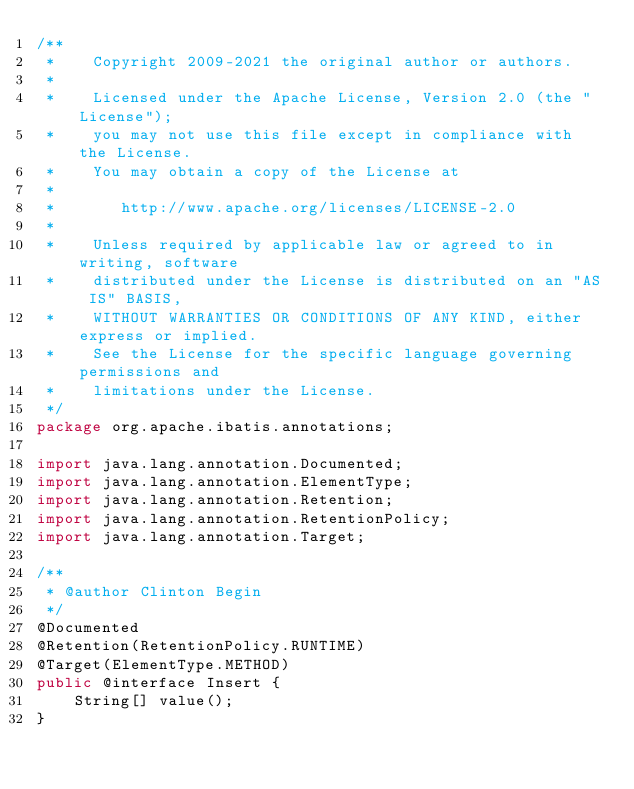<code> <loc_0><loc_0><loc_500><loc_500><_Java_>/**
 *    Copyright 2009-2021 the original author or authors.
 *
 *    Licensed under the Apache License, Version 2.0 (the "License");
 *    you may not use this file except in compliance with the License.
 *    You may obtain a copy of the License at
 *
 *       http://www.apache.org/licenses/LICENSE-2.0
 *
 *    Unless required by applicable law or agreed to in writing, software
 *    distributed under the License is distributed on an "AS IS" BASIS,
 *    WITHOUT WARRANTIES OR CONDITIONS OF ANY KIND, either express or implied.
 *    See the License for the specific language governing permissions and
 *    limitations under the License.
 */
package org.apache.ibatis.annotations;

import java.lang.annotation.Documented;
import java.lang.annotation.ElementType;
import java.lang.annotation.Retention;
import java.lang.annotation.RetentionPolicy;
import java.lang.annotation.Target;

/**
 * @author Clinton Begin
 */
@Documented
@Retention(RetentionPolicy.RUNTIME)
@Target(ElementType.METHOD)
public @interface Insert {
    String[] value();
}
</code> 